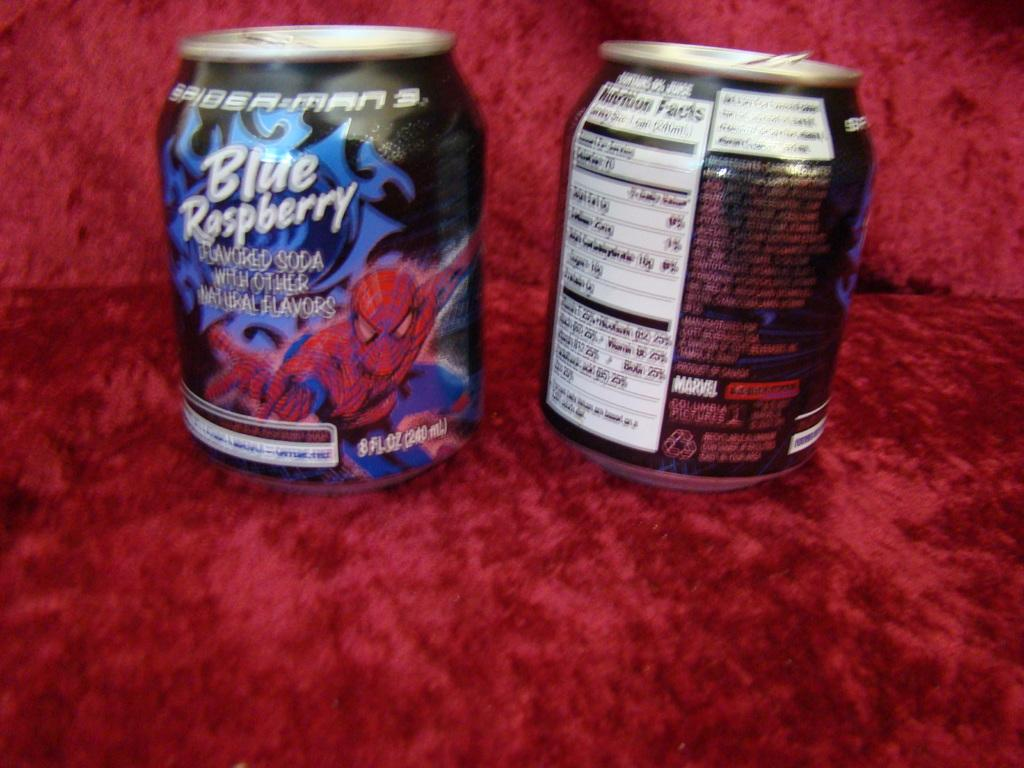<image>
Share a concise interpretation of the image provided. Two cans sit side by side and show the front and back of a blue raspberry flavored soda. 